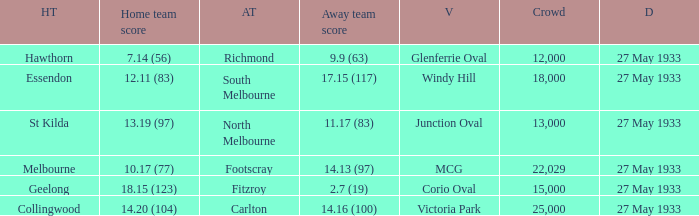Can you give me this table as a dict? {'header': ['HT', 'Home team score', 'AT', 'Away team score', 'V', 'Crowd', 'D'], 'rows': [['Hawthorn', '7.14 (56)', 'Richmond', '9.9 (63)', 'Glenferrie Oval', '12,000', '27 May 1933'], ['Essendon', '12.11 (83)', 'South Melbourne', '17.15 (117)', 'Windy Hill', '18,000', '27 May 1933'], ['St Kilda', '13.19 (97)', 'North Melbourne', '11.17 (83)', 'Junction Oval', '13,000', '27 May 1933'], ['Melbourne', '10.17 (77)', 'Footscray', '14.13 (97)', 'MCG', '22,029', '27 May 1933'], ['Geelong', '18.15 (123)', 'Fitzroy', '2.7 (19)', 'Corio Oval', '15,000', '27 May 1933'], ['Collingwood', '14.20 (104)', 'Carlton', '14.16 (100)', 'Victoria Park', '25,000', '27 May 1933']]} During st kilda's home game, what was the number of people in the crowd? 13000.0. 